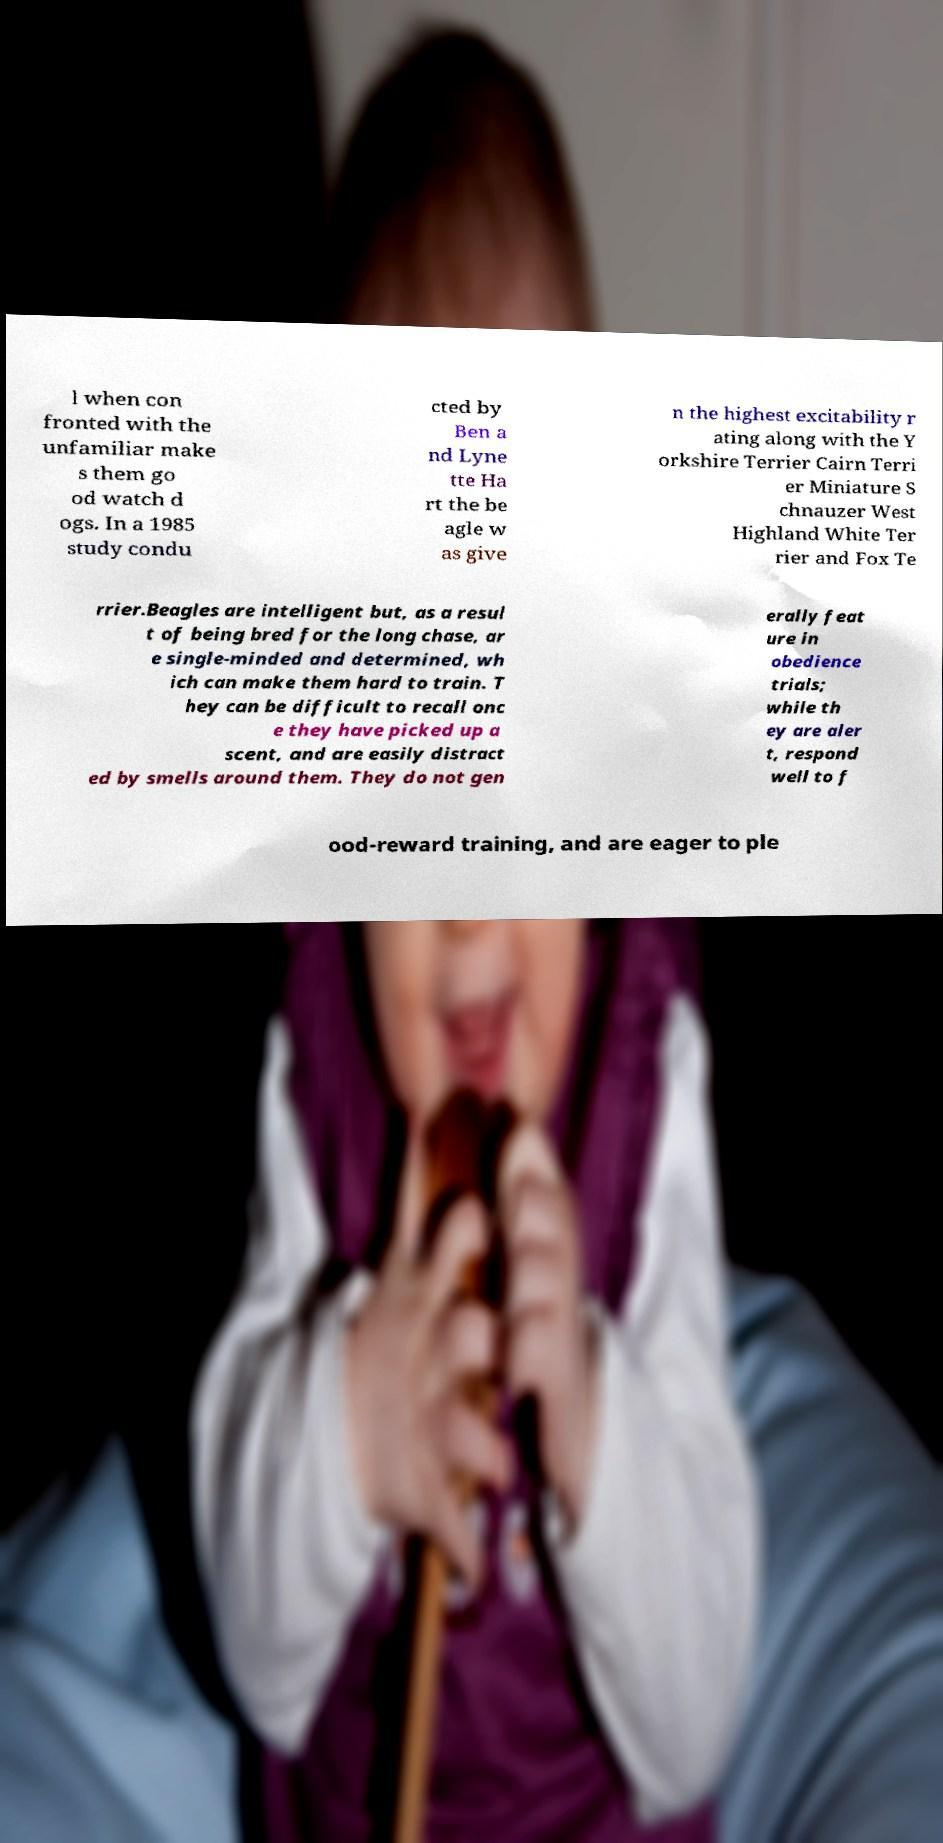For documentation purposes, I need the text within this image transcribed. Could you provide that? l when con fronted with the unfamiliar make s them go od watch d ogs. In a 1985 study condu cted by Ben a nd Lyne tte Ha rt the be agle w as give n the highest excitability r ating along with the Y orkshire Terrier Cairn Terri er Miniature S chnauzer West Highland White Ter rier and Fox Te rrier.Beagles are intelligent but, as a resul t of being bred for the long chase, ar e single-minded and determined, wh ich can make them hard to train. T hey can be difficult to recall onc e they have picked up a scent, and are easily distract ed by smells around them. They do not gen erally feat ure in obedience trials; while th ey are aler t, respond well to f ood-reward training, and are eager to ple 